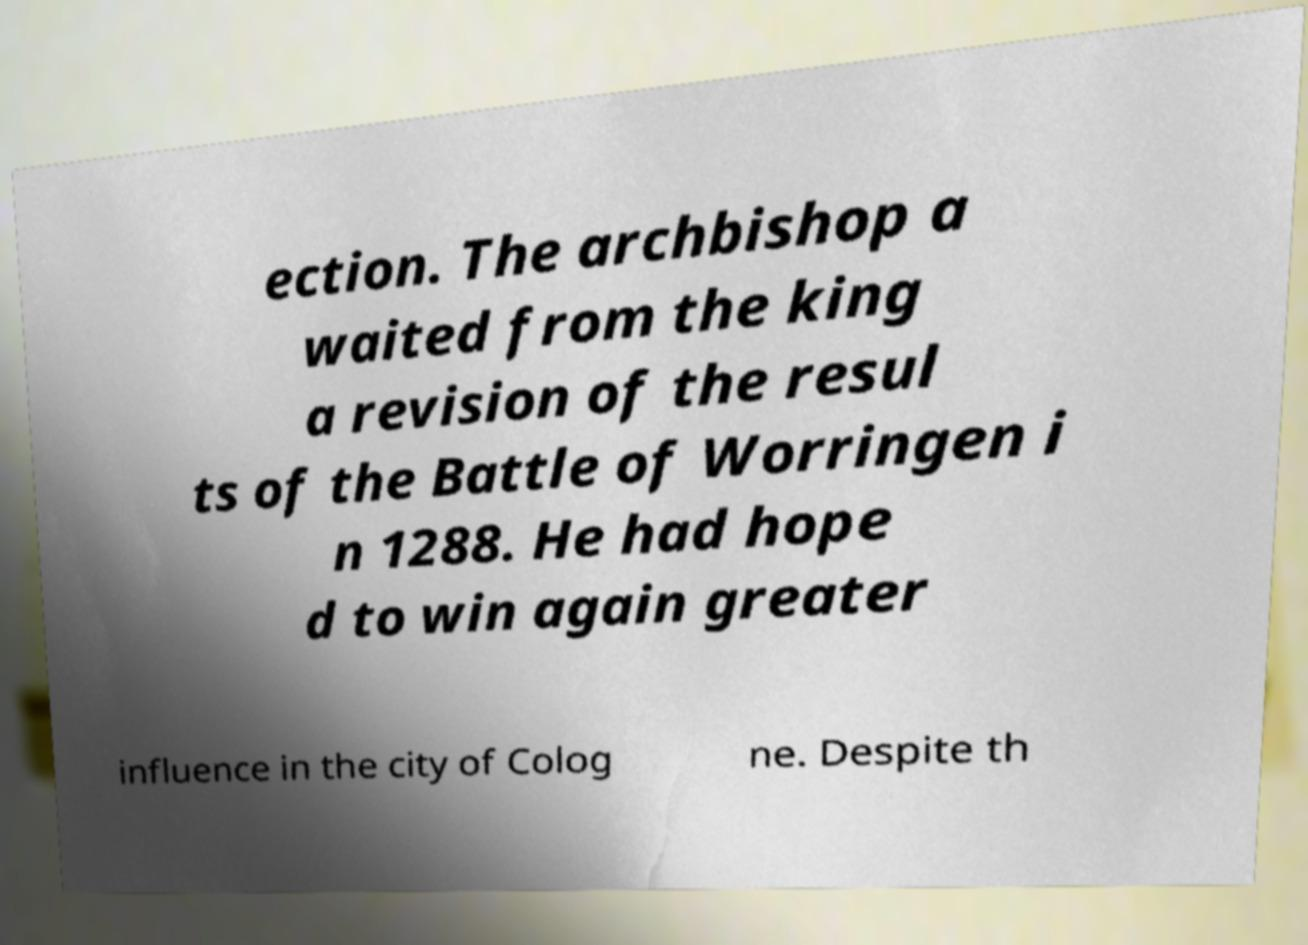What messages or text are displayed in this image? I need them in a readable, typed format. ection. The archbishop a waited from the king a revision of the resul ts of the Battle of Worringen i n 1288. He had hope d to win again greater influence in the city of Colog ne. Despite th 